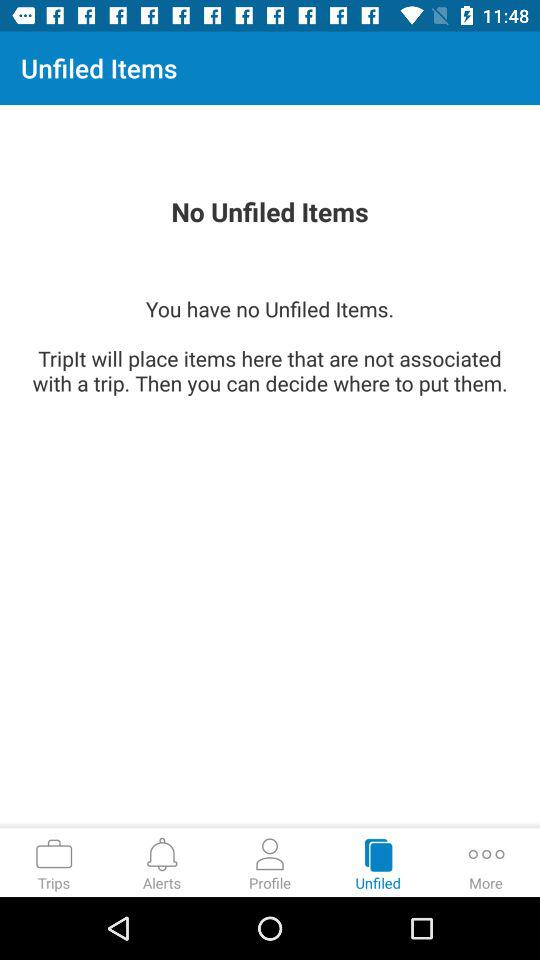How many characters should the password have? The password should have at least 8 characters. 